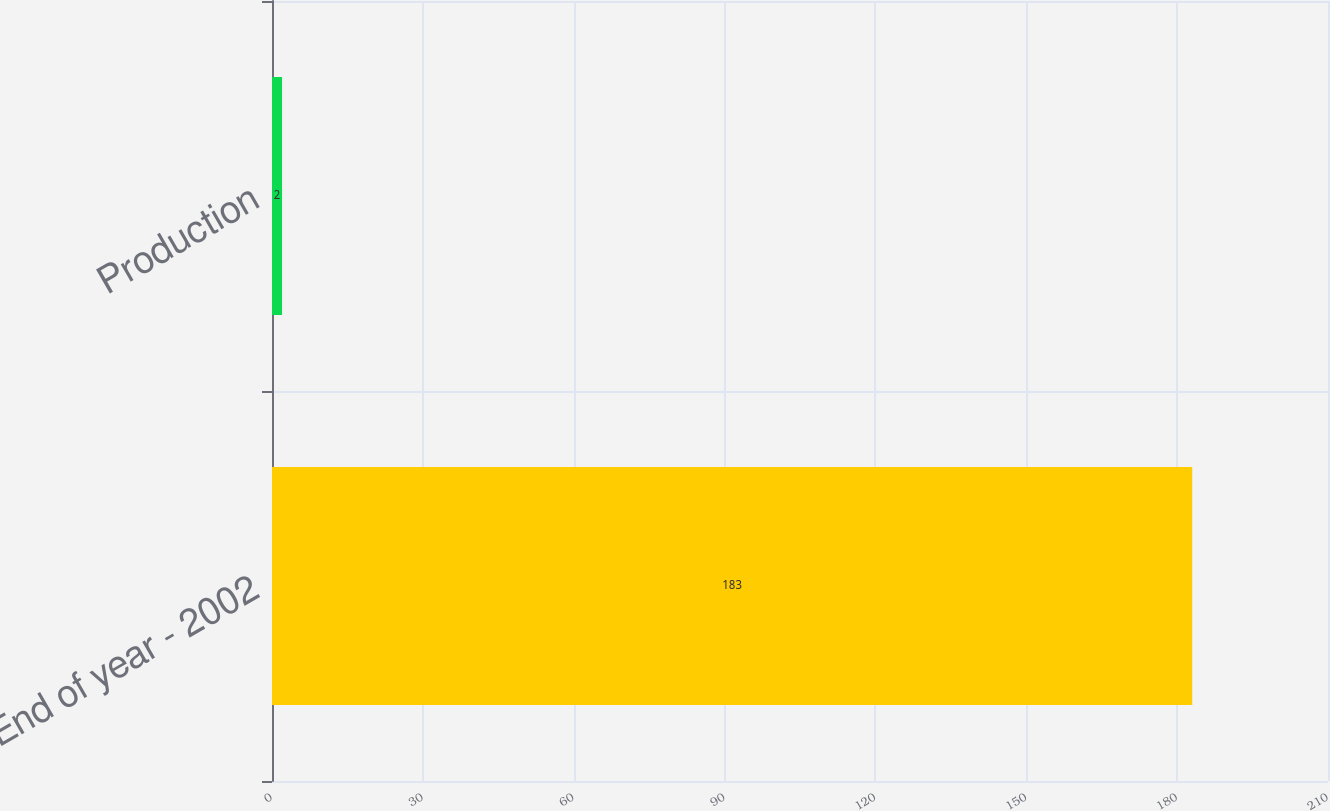<chart> <loc_0><loc_0><loc_500><loc_500><bar_chart><fcel>End of year - 2002<fcel>Production<nl><fcel>183<fcel>2<nl></chart> 